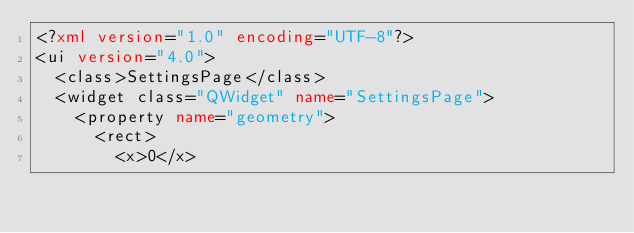Convert code to text. <code><loc_0><loc_0><loc_500><loc_500><_XML_><?xml version="1.0" encoding="UTF-8"?>
<ui version="4.0">
	<class>SettingsPage</class>
	<widget class="QWidget" name="SettingsPage">
		<property name="geometry">
			<rect>
				<x>0</x></code> 